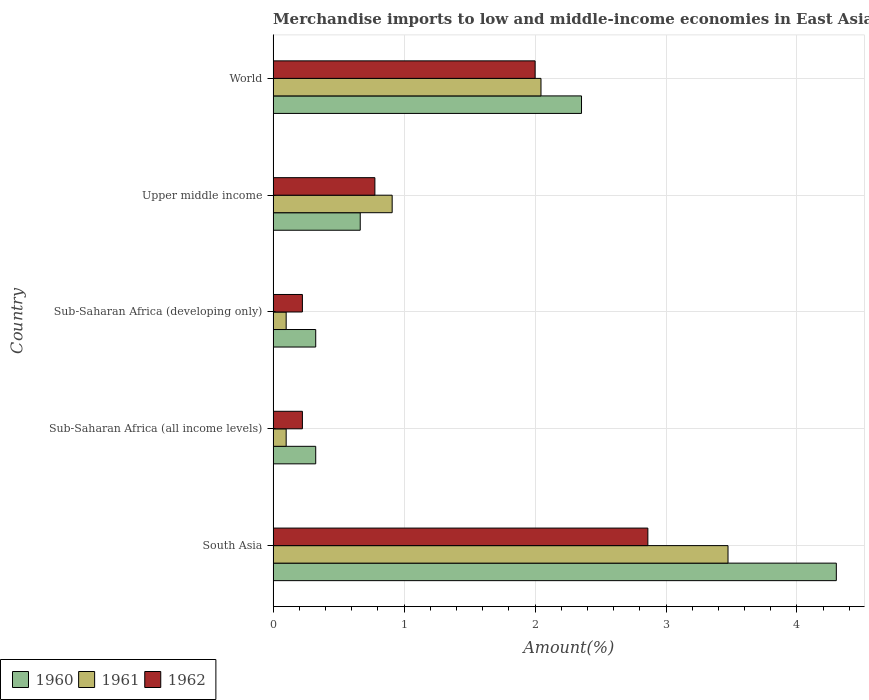How many groups of bars are there?
Ensure brevity in your answer.  5. How many bars are there on the 2nd tick from the top?
Provide a short and direct response. 3. What is the label of the 4th group of bars from the top?
Give a very brief answer. Sub-Saharan Africa (all income levels). In how many cases, is the number of bars for a given country not equal to the number of legend labels?
Your answer should be very brief. 0. What is the percentage of amount earned from merchandise imports in 1960 in Sub-Saharan Africa (developing only)?
Offer a very short reply. 0.33. Across all countries, what is the maximum percentage of amount earned from merchandise imports in 1961?
Provide a short and direct response. 3.47. Across all countries, what is the minimum percentage of amount earned from merchandise imports in 1960?
Make the answer very short. 0.33. In which country was the percentage of amount earned from merchandise imports in 1962 minimum?
Provide a succinct answer. Sub-Saharan Africa (all income levels). What is the total percentage of amount earned from merchandise imports in 1961 in the graph?
Ensure brevity in your answer.  6.63. What is the difference between the percentage of amount earned from merchandise imports in 1962 in Sub-Saharan Africa (all income levels) and that in Upper middle income?
Your answer should be compact. -0.55. What is the difference between the percentage of amount earned from merchandise imports in 1962 in Sub-Saharan Africa (all income levels) and the percentage of amount earned from merchandise imports in 1961 in South Asia?
Ensure brevity in your answer.  -3.25. What is the average percentage of amount earned from merchandise imports in 1961 per country?
Offer a very short reply. 1.33. What is the difference between the percentage of amount earned from merchandise imports in 1962 and percentage of amount earned from merchandise imports in 1961 in South Asia?
Offer a very short reply. -0.61. In how many countries, is the percentage of amount earned from merchandise imports in 1960 greater than 3 %?
Keep it short and to the point. 1. What is the ratio of the percentage of amount earned from merchandise imports in 1960 in South Asia to that in World?
Your answer should be compact. 1.83. Is the percentage of amount earned from merchandise imports in 1962 in South Asia less than that in Upper middle income?
Offer a terse response. No. What is the difference between the highest and the second highest percentage of amount earned from merchandise imports in 1960?
Ensure brevity in your answer.  1.95. What is the difference between the highest and the lowest percentage of amount earned from merchandise imports in 1960?
Provide a short and direct response. 3.98. In how many countries, is the percentage of amount earned from merchandise imports in 1960 greater than the average percentage of amount earned from merchandise imports in 1960 taken over all countries?
Provide a short and direct response. 2. What does the 3rd bar from the top in Sub-Saharan Africa (all income levels) represents?
Provide a short and direct response. 1960. What does the 2nd bar from the bottom in Upper middle income represents?
Provide a short and direct response. 1961. Is it the case that in every country, the sum of the percentage of amount earned from merchandise imports in 1961 and percentage of amount earned from merchandise imports in 1960 is greater than the percentage of amount earned from merchandise imports in 1962?
Your answer should be compact. Yes. How many bars are there?
Give a very brief answer. 15. Are all the bars in the graph horizontal?
Provide a short and direct response. Yes. How many countries are there in the graph?
Give a very brief answer. 5. What is the difference between two consecutive major ticks on the X-axis?
Ensure brevity in your answer.  1. Does the graph contain any zero values?
Make the answer very short. No. How many legend labels are there?
Give a very brief answer. 3. What is the title of the graph?
Provide a succinct answer. Merchandise imports to low and middle-income economies in East Asia & Pacific. What is the label or title of the X-axis?
Make the answer very short. Amount(%). What is the label or title of the Y-axis?
Ensure brevity in your answer.  Country. What is the Amount(%) in 1960 in South Asia?
Your answer should be compact. 4.3. What is the Amount(%) in 1961 in South Asia?
Your response must be concise. 3.47. What is the Amount(%) in 1962 in South Asia?
Offer a very short reply. 2.86. What is the Amount(%) in 1960 in Sub-Saharan Africa (all income levels)?
Provide a short and direct response. 0.33. What is the Amount(%) of 1961 in Sub-Saharan Africa (all income levels)?
Give a very brief answer. 0.1. What is the Amount(%) in 1962 in Sub-Saharan Africa (all income levels)?
Offer a very short reply. 0.22. What is the Amount(%) of 1960 in Sub-Saharan Africa (developing only)?
Provide a short and direct response. 0.33. What is the Amount(%) in 1961 in Sub-Saharan Africa (developing only)?
Offer a very short reply. 0.1. What is the Amount(%) in 1962 in Sub-Saharan Africa (developing only)?
Your response must be concise. 0.22. What is the Amount(%) in 1960 in Upper middle income?
Provide a short and direct response. 0.67. What is the Amount(%) in 1961 in Upper middle income?
Ensure brevity in your answer.  0.91. What is the Amount(%) of 1962 in Upper middle income?
Give a very brief answer. 0.78. What is the Amount(%) in 1960 in World?
Provide a short and direct response. 2.35. What is the Amount(%) of 1961 in World?
Offer a very short reply. 2.05. What is the Amount(%) of 1962 in World?
Ensure brevity in your answer.  2. Across all countries, what is the maximum Amount(%) in 1960?
Your response must be concise. 4.3. Across all countries, what is the maximum Amount(%) in 1961?
Provide a succinct answer. 3.47. Across all countries, what is the maximum Amount(%) of 1962?
Provide a succinct answer. 2.86. Across all countries, what is the minimum Amount(%) in 1960?
Your answer should be compact. 0.33. Across all countries, what is the minimum Amount(%) of 1961?
Make the answer very short. 0.1. Across all countries, what is the minimum Amount(%) of 1962?
Make the answer very short. 0.22. What is the total Amount(%) of 1960 in the graph?
Give a very brief answer. 7.97. What is the total Amount(%) of 1961 in the graph?
Give a very brief answer. 6.63. What is the total Amount(%) of 1962 in the graph?
Give a very brief answer. 6.09. What is the difference between the Amount(%) of 1960 in South Asia and that in Sub-Saharan Africa (all income levels)?
Your response must be concise. 3.98. What is the difference between the Amount(%) in 1961 in South Asia and that in Sub-Saharan Africa (all income levels)?
Your answer should be very brief. 3.37. What is the difference between the Amount(%) in 1962 in South Asia and that in Sub-Saharan Africa (all income levels)?
Offer a very short reply. 2.64. What is the difference between the Amount(%) in 1960 in South Asia and that in Sub-Saharan Africa (developing only)?
Your answer should be very brief. 3.98. What is the difference between the Amount(%) in 1961 in South Asia and that in Sub-Saharan Africa (developing only)?
Keep it short and to the point. 3.37. What is the difference between the Amount(%) of 1962 in South Asia and that in Sub-Saharan Africa (developing only)?
Offer a very short reply. 2.64. What is the difference between the Amount(%) of 1960 in South Asia and that in Upper middle income?
Give a very brief answer. 3.64. What is the difference between the Amount(%) in 1961 in South Asia and that in Upper middle income?
Your response must be concise. 2.56. What is the difference between the Amount(%) of 1962 in South Asia and that in Upper middle income?
Your response must be concise. 2.08. What is the difference between the Amount(%) of 1960 in South Asia and that in World?
Keep it short and to the point. 1.95. What is the difference between the Amount(%) in 1961 in South Asia and that in World?
Provide a short and direct response. 1.43. What is the difference between the Amount(%) in 1962 in South Asia and that in World?
Your response must be concise. 0.86. What is the difference between the Amount(%) of 1961 in Sub-Saharan Africa (all income levels) and that in Sub-Saharan Africa (developing only)?
Offer a terse response. 0. What is the difference between the Amount(%) of 1962 in Sub-Saharan Africa (all income levels) and that in Sub-Saharan Africa (developing only)?
Keep it short and to the point. 0. What is the difference between the Amount(%) in 1960 in Sub-Saharan Africa (all income levels) and that in Upper middle income?
Provide a succinct answer. -0.34. What is the difference between the Amount(%) in 1961 in Sub-Saharan Africa (all income levels) and that in Upper middle income?
Your response must be concise. -0.81. What is the difference between the Amount(%) of 1962 in Sub-Saharan Africa (all income levels) and that in Upper middle income?
Your answer should be compact. -0.55. What is the difference between the Amount(%) of 1960 in Sub-Saharan Africa (all income levels) and that in World?
Your response must be concise. -2.03. What is the difference between the Amount(%) of 1961 in Sub-Saharan Africa (all income levels) and that in World?
Your response must be concise. -1.95. What is the difference between the Amount(%) in 1962 in Sub-Saharan Africa (all income levels) and that in World?
Your answer should be very brief. -1.78. What is the difference between the Amount(%) of 1960 in Sub-Saharan Africa (developing only) and that in Upper middle income?
Ensure brevity in your answer.  -0.34. What is the difference between the Amount(%) of 1961 in Sub-Saharan Africa (developing only) and that in Upper middle income?
Make the answer very short. -0.81. What is the difference between the Amount(%) of 1962 in Sub-Saharan Africa (developing only) and that in Upper middle income?
Offer a terse response. -0.55. What is the difference between the Amount(%) of 1960 in Sub-Saharan Africa (developing only) and that in World?
Your answer should be very brief. -2.03. What is the difference between the Amount(%) in 1961 in Sub-Saharan Africa (developing only) and that in World?
Provide a succinct answer. -1.95. What is the difference between the Amount(%) in 1962 in Sub-Saharan Africa (developing only) and that in World?
Provide a short and direct response. -1.78. What is the difference between the Amount(%) of 1960 in Upper middle income and that in World?
Offer a very short reply. -1.69. What is the difference between the Amount(%) in 1961 in Upper middle income and that in World?
Provide a short and direct response. -1.14. What is the difference between the Amount(%) in 1962 in Upper middle income and that in World?
Your answer should be compact. -1.22. What is the difference between the Amount(%) in 1960 in South Asia and the Amount(%) in 1961 in Sub-Saharan Africa (all income levels)?
Make the answer very short. 4.2. What is the difference between the Amount(%) in 1960 in South Asia and the Amount(%) in 1962 in Sub-Saharan Africa (all income levels)?
Your answer should be compact. 4.08. What is the difference between the Amount(%) in 1961 in South Asia and the Amount(%) in 1962 in Sub-Saharan Africa (all income levels)?
Your answer should be compact. 3.25. What is the difference between the Amount(%) of 1960 in South Asia and the Amount(%) of 1961 in Sub-Saharan Africa (developing only)?
Offer a terse response. 4.2. What is the difference between the Amount(%) in 1960 in South Asia and the Amount(%) in 1962 in Sub-Saharan Africa (developing only)?
Make the answer very short. 4.08. What is the difference between the Amount(%) of 1961 in South Asia and the Amount(%) of 1962 in Sub-Saharan Africa (developing only)?
Offer a very short reply. 3.25. What is the difference between the Amount(%) of 1960 in South Asia and the Amount(%) of 1961 in Upper middle income?
Your answer should be compact. 3.39. What is the difference between the Amount(%) in 1960 in South Asia and the Amount(%) in 1962 in Upper middle income?
Ensure brevity in your answer.  3.52. What is the difference between the Amount(%) in 1961 in South Asia and the Amount(%) in 1962 in Upper middle income?
Give a very brief answer. 2.7. What is the difference between the Amount(%) of 1960 in South Asia and the Amount(%) of 1961 in World?
Provide a succinct answer. 2.26. What is the difference between the Amount(%) in 1961 in South Asia and the Amount(%) in 1962 in World?
Make the answer very short. 1.47. What is the difference between the Amount(%) in 1960 in Sub-Saharan Africa (all income levels) and the Amount(%) in 1961 in Sub-Saharan Africa (developing only)?
Your response must be concise. 0.23. What is the difference between the Amount(%) of 1960 in Sub-Saharan Africa (all income levels) and the Amount(%) of 1962 in Sub-Saharan Africa (developing only)?
Offer a very short reply. 0.1. What is the difference between the Amount(%) of 1961 in Sub-Saharan Africa (all income levels) and the Amount(%) of 1962 in Sub-Saharan Africa (developing only)?
Keep it short and to the point. -0.12. What is the difference between the Amount(%) of 1960 in Sub-Saharan Africa (all income levels) and the Amount(%) of 1961 in Upper middle income?
Your answer should be compact. -0.58. What is the difference between the Amount(%) of 1960 in Sub-Saharan Africa (all income levels) and the Amount(%) of 1962 in Upper middle income?
Offer a very short reply. -0.45. What is the difference between the Amount(%) of 1961 in Sub-Saharan Africa (all income levels) and the Amount(%) of 1962 in Upper middle income?
Give a very brief answer. -0.68. What is the difference between the Amount(%) of 1960 in Sub-Saharan Africa (all income levels) and the Amount(%) of 1961 in World?
Give a very brief answer. -1.72. What is the difference between the Amount(%) of 1960 in Sub-Saharan Africa (all income levels) and the Amount(%) of 1962 in World?
Ensure brevity in your answer.  -1.68. What is the difference between the Amount(%) in 1961 in Sub-Saharan Africa (all income levels) and the Amount(%) in 1962 in World?
Your response must be concise. -1.9. What is the difference between the Amount(%) of 1960 in Sub-Saharan Africa (developing only) and the Amount(%) of 1961 in Upper middle income?
Your answer should be very brief. -0.58. What is the difference between the Amount(%) of 1960 in Sub-Saharan Africa (developing only) and the Amount(%) of 1962 in Upper middle income?
Your answer should be very brief. -0.45. What is the difference between the Amount(%) of 1961 in Sub-Saharan Africa (developing only) and the Amount(%) of 1962 in Upper middle income?
Make the answer very short. -0.68. What is the difference between the Amount(%) of 1960 in Sub-Saharan Africa (developing only) and the Amount(%) of 1961 in World?
Ensure brevity in your answer.  -1.72. What is the difference between the Amount(%) of 1960 in Sub-Saharan Africa (developing only) and the Amount(%) of 1962 in World?
Offer a terse response. -1.68. What is the difference between the Amount(%) in 1961 in Sub-Saharan Africa (developing only) and the Amount(%) in 1962 in World?
Make the answer very short. -1.9. What is the difference between the Amount(%) in 1960 in Upper middle income and the Amount(%) in 1961 in World?
Provide a succinct answer. -1.38. What is the difference between the Amount(%) in 1960 in Upper middle income and the Amount(%) in 1962 in World?
Keep it short and to the point. -1.34. What is the difference between the Amount(%) of 1961 in Upper middle income and the Amount(%) of 1962 in World?
Your response must be concise. -1.09. What is the average Amount(%) in 1960 per country?
Ensure brevity in your answer.  1.59. What is the average Amount(%) of 1961 per country?
Offer a very short reply. 1.33. What is the average Amount(%) in 1962 per country?
Your response must be concise. 1.22. What is the difference between the Amount(%) in 1960 and Amount(%) in 1961 in South Asia?
Make the answer very short. 0.83. What is the difference between the Amount(%) of 1960 and Amount(%) of 1962 in South Asia?
Your response must be concise. 1.44. What is the difference between the Amount(%) in 1961 and Amount(%) in 1962 in South Asia?
Ensure brevity in your answer.  0.61. What is the difference between the Amount(%) in 1960 and Amount(%) in 1961 in Sub-Saharan Africa (all income levels)?
Ensure brevity in your answer.  0.23. What is the difference between the Amount(%) of 1960 and Amount(%) of 1962 in Sub-Saharan Africa (all income levels)?
Your answer should be very brief. 0.1. What is the difference between the Amount(%) of 1961 and Amount(%) of 1962 in Sub-Saharan Africa (all income levels)?
Offer a terse response. -0.12. What is the difference between the Amount(%) of 1960 and Amount(%) of 1961 in Sub-Saharan Africa (developing only)?
Your answer should be very brief. 0.23. What is the difference between the Amount(%) in 1960 and Amount(%) in 1962 in Sub-Saharan Africa (developing only)?
Offer a very short reply. 0.1. What is the difference between the Amount(%) of 1961 and Amount(%) of 1962 in Sub-Saharan Africa (developing only)?
Your answer should be compact. -0.12. What is the difference between the Amount(%) in 1960 and Amount(%) in 1961 in Upper middle income?
Your answer should be very brief. -0.24. What is the difference between the Amount(%) in 1960 and Amount(%) in 1962 in Upper middle income?
Provide a succinct answer. -0.11. What is the difference between the Amount(%) of 1961 and Amount(%) of 1962 in Upper middle income?
Ensure brevity in your answer.  0.13. What is the difference between the Amount(%) of 1960 and Amount(%) of 1961 in World?
Make the answer very short. 0.31. What is the difference between the Amount(%) of 1960 and Amount(%) of 1962 in World?
Offer a terse response. 0.35. What is the difference between the Amount(%) in 1961 and Amount(%) in 1962 in World?
Ensure brevity in your answer.  0.04. What is the ratio of the Amount(%) in 1960 in South Asia to that in Sub-Saharan Africa (all income levels)?
Your answer should be very brief. 13.22. What is the ratio of the Amount(%) in 1961 in South Asia to that in Sub-Saharan Africa (all income levels)?
Provide a short and direct response. 34.86. What is the ratio of the Amount(%) in 1962 in South Asia to that in Sub-Saharan Africa (all income levels)?
Ensure brevity in your answer.  12.8. What is the ratio of the Amount(%) of 1960 in South Asia to that in Sub-Saharan Africa (developing only)?
Your answer should be very brief. 13.22. What is the ratio of the Amount(%) in 1961 in South Asia to that in Sub-Saharan Africa (developing only)?
Keep it short and to the point. 34.86. What is the ratio of the Amount(%) in 1962 in South Asia to that in Sub-Saharan Africa (developing only)?
Provide a succinct answer. 12.8. What is the ratio of the Amount(%) of 1960 in South Asia to that in Upper middle income?
Offer a very short reply. 6.47. What is the ratio of the Amount(%) in 1961 in South Asia to that in Upper middle income?
Keep it short and to the point. 3.82. What is the ratio of the Amount(%) in 1962 in South Asia to that in Upper middle income?
Your answer should be compact. 3.68. What is the ratio of the Amount(%) in 1960 in South Asia to that in World?
Provide a short and direct response. 1.83. What is the ratio of the Amount(%) in 1961 in South Asia to that in World?
Ensure brevity in your answer.  1.7. What is the ratio of the Amount(%) of 1962 in South Asia to that in World?
Provide a short and direct response. 1.43. What is the ratio of the Amount(%) in 1960 in Sub-Saharan Africa (all income levels) to that in Upper middle income?
Provide a succinct answer. 0.49. What is the ratio of the Amount(%) of 1961 in Sub-Saharan Africa (all income levels) to that in Upper middle income?
Offer a terse response. 0.11. What is the ratio of the Amount(%) in 1962 in Sub-Saharan Africa (all income levels) to that in Upper middle income?
Provide a short and direct response. 0.29. What is the ratio of the Amount(%) of 1960 in Sub-Saharan Africa (all income levels) to that in World?
Ensure brevity in your answer.  0.14. What is the ratio of the Amount(%) of 1961 in Sub-Saharan Africa (all income levels) to that in World?
Your answer should be very brief. 0.05. What is the ratio of the Amount(%) of 1962 in Sub-Saharan Africa (all income levels) to that in World?
Ensure brevity in your answer.  0.11. What is the ratio of the Amount(%) in 1960 in Sub-Saharan Africa (developing only) to that in Upper middle income?
Your response must be concise. 0.49. What is the ratio of the Amount(%) in 1961 in Sub-Saharan Africa (developing only) to that in Upper middle income?
Provide a succinct answer. 0.11. What is the ratio of the Amount(%) in 1962 in Sub-Saharan Africa (developing only) to that in Upper middle income?
Provide a short and direct response. 0.29. What is the ratio of the Amount(%) of 1960 in Sub-Saharan Africa (developing only) to that in World?
Your response must be concise. 0.14. What is the ratio of the Amount(%) in 1961 in Sub-Saharan Africa (developing only) to that in World?
Ensure brevity in your answer.  0.05. What is the ratio of the Amount(%) of 1962 in Sub-Saharan Africa (developing only) to that in World?
Ensure brevity in your answer.  0.11. What is the ratio of the Amount(%) of 1960 in Upper middle income to that in World?
Offer a terse response. 0.28. What is the ratio of the Amount(%) of 1961 in Upper middle income to that in World?
Make the answer very short. 0.44. What is the ratio of the Amount(%) of 1962 in Upper middle income to that in World?
Offer a very short reply. 0.39. What is the difference between the highest and the second highest Amount(%) in 1960?
Offer a very short reply. 1.95. What is the difference between the highest and the second highest Amount(%) in 1961?
Ensure brevity in your answer.  1.43. What is the difference between the highest and the second highest Amount(%) in 1962?
Make the answer very short. 0.86. What is the difference between the highest and the lowest Amount(%) of 1960?
Your answer should be very brief. 3.98. What is the difference between the highest and the lowest Amount(%) of 1961?
Your answer should be very brief. 3.37. What is the difference between the highest and the lowest Amount(%) of 1962?
Ensure brevity in your answer.  2.64. 